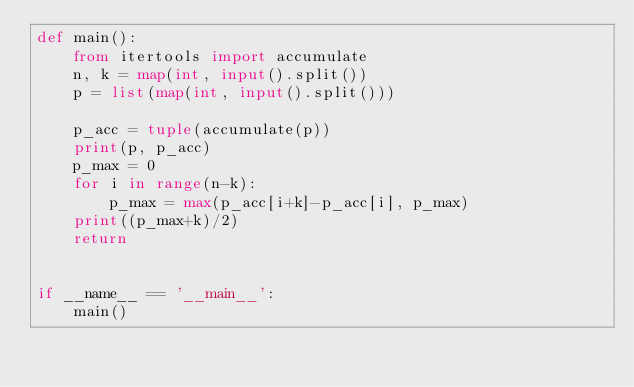Convert code to text. <code><loc_0><loc_0><loc_500><loc_500><_Python_>def main():
    from itertools import accumulate
    n, k = map(int, input().split())
    p = list(map(int, input().split()))

    p_acc = tuple(accumulate(p))
    print(p, p_acc)
    p_max = 0
    for i in range(n-k):
        p_max = max(p_acc[i+k]-p_acc[i], p_max)
    print((p_max+k)/2)
    return


if __name__ == '__main__':
    main()
</code> 